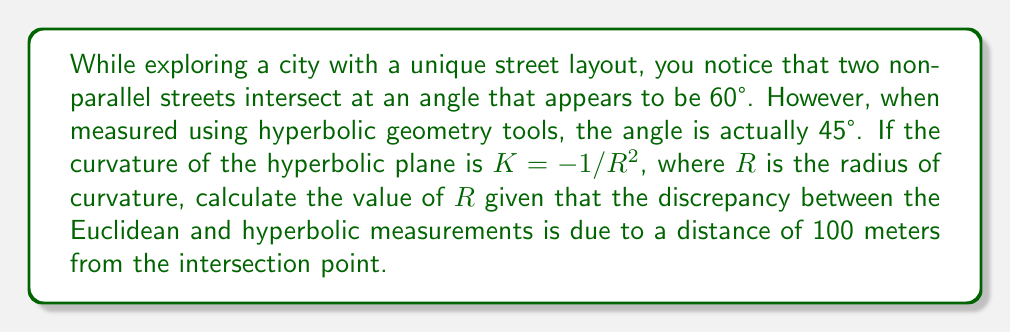Teach me how to tackle this problem. Let's approach this step-by-step:

1) In hyperbolic geometry, the relationship between Euclidean angle $\alpha$ and hyperbolic angle $\theta$ at a distance $r$ from the center of a hyperbolic circle is given by:

   $$\tan(\frac{\alpha}{2}) = \sinh(\frac{r}{R})\tan(\frac{\theta}{2})$$

   Where $R$ is the radius of curvature.

2) We're given:
   - Euclidean angle $\alpha = 60°$
   - Hyperbolic angle $\theta = 45°$
   - Distance $r = 100$ meters

3) Let's substitute these values into the equation:

   $$\tan(30°) = \sinh(\frac{100}{R})\tan(22.5°)$$

4) Simplify the known values:

   $$\frac{\sqrt{3}}{3} = \sinh(\frac{100}{R}) \cdot (\sqrt{2}-1)$$

5) Divide both sides by $(\sqrt{2}-1)$:

   $$\frac{\sqrt{3}}{3(\sqrt{2}-1)} = \sinh(\frac{100}{R})$$

6) Take the inverse hyperbolic sine (arsinh) of both sides:

   $$\text{arsinh}(\frac{\sqrt{3}}{3(\sqrt{2}-1)}) = \frac{100}{R}$$

7) Solve for $R$:

   $$R = \frac{100}{\text{arsinh}(\frac{\sqrt{3}}{3(\sqrt{2}-1)})}$$

8) Calculate the value (you can use a calculator for this):

   $$R \approx 78.13\text{ meters}$$
Answer: $R \approx 78.13\text{ meters}$ 